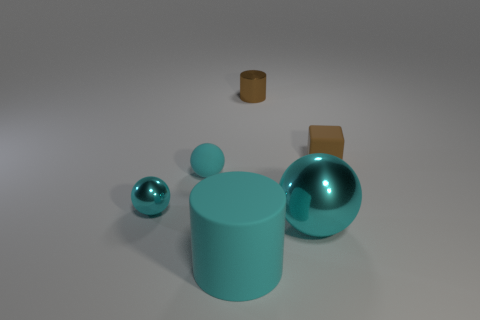Add 3 tiny green matte cylinders. How many objects exist? 9 Subtract all blocks. How many objects are left? 5 Add 5 shiny objects. How many shiny objects are left? 8 Add 3 rubber objects. How many rubber objects exist? 6 Subtract 1 brown cubes. How many objects are left? 5 Subtract all brown spheres. Subtract all brown matte objects. How many objects are left? 5 